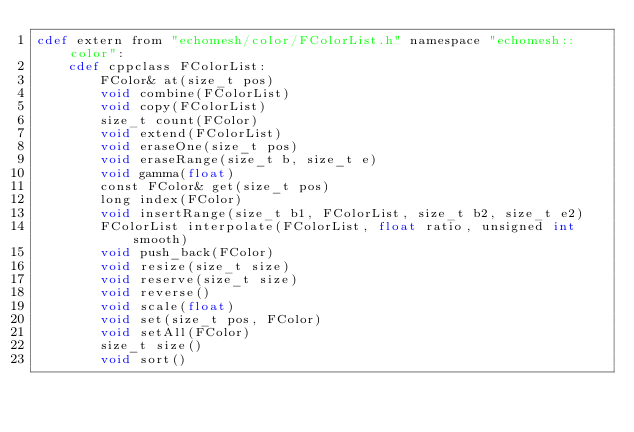<code> <loc_0><loc_0><loc_500><loc_500><_Cython_>cdef extern from "echomesh/color/FColorList.h" namespace "echomesh::color":
    cdef cppclass FColorList:
        FColor& at(size_t pos)
        void combine(FColorList)
        void copy(FColorList)
        size_t count(FColor)
        void extend(FColorList)
        void eraseOne(size_t pos)
        void eraseRange(size_t b, size_t e)
        void gamma(float)
        const FColor& get(size_t pos)
        long index(FColor)
        void insertRange(size_t b1, FColorList, size_t b2, size_t e2)
        FColorList interpolate(FColorList, float ratio, unsigned int smooth)
        void push_back(FColor)
        void resize(size_t size)
        void reserve(size_t size)
        void reverse()
        void scale(float)
        void set(size_t pos, FColor)
        void setAll(FColor)
        size_t size()
        void sort()
</code> 